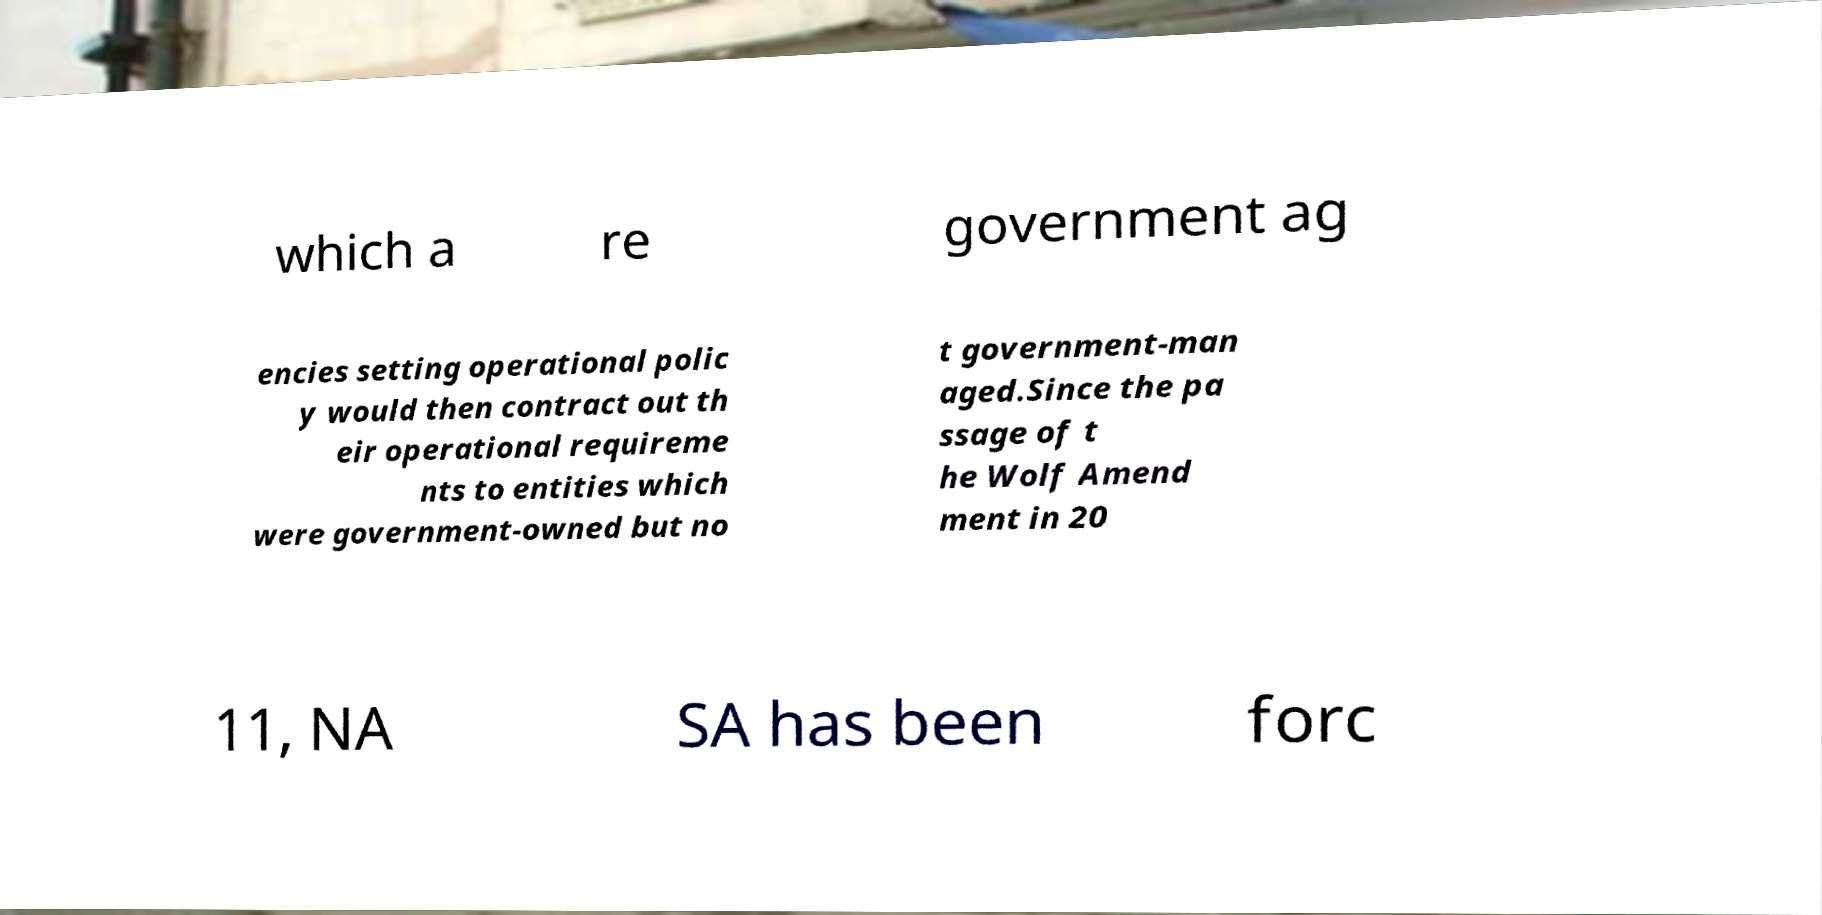I need the written content from this picture converted into text. Can you do that? which a re government ag encies setting operational polic y would then contract out th eir operational requireme nts to entities which were government-owned but no t government-man aged.Since the pa ssage of t he Wolf Amend ment in 20 11, NA SA has been forc 